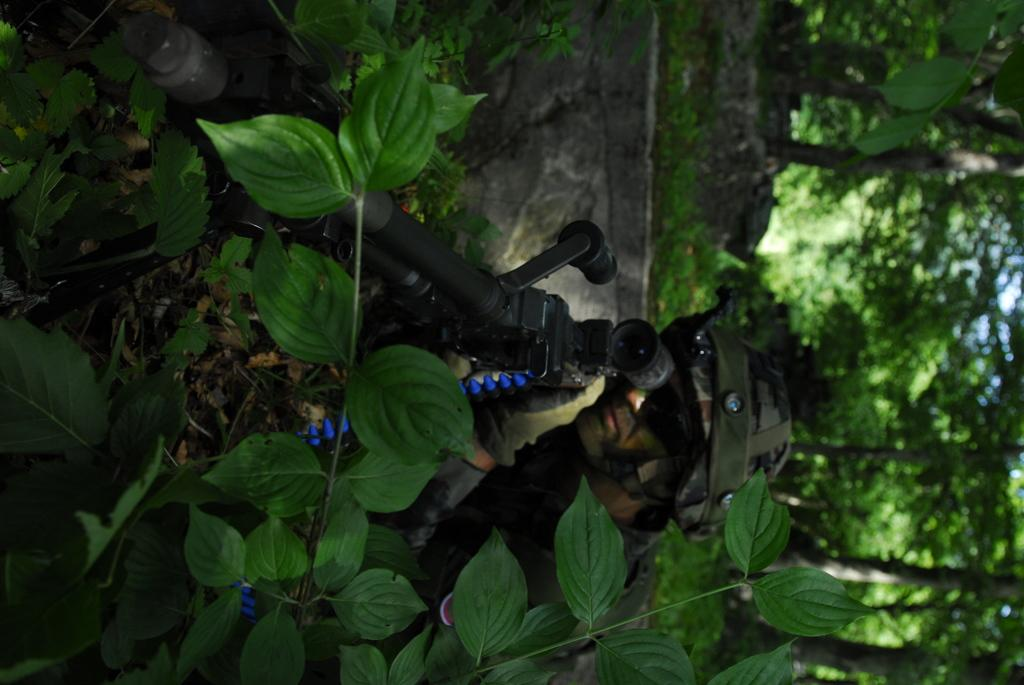What is the person in the image holding? The person in the image is holding a gun. What type of vegetation can be seen in the image? There are plants and trees in the image. What is visible in the background of the image? The sky is visible in the image. How does the person in the image help the thread to jump over the trees? There is no thread or jumping involved in the image; the person is simply holding a gun. 